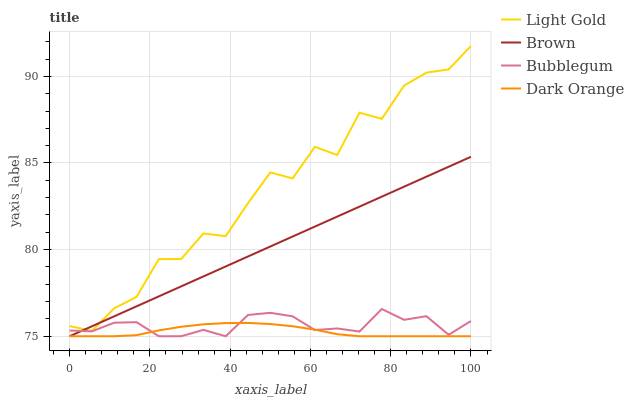Does Dark Orange have the minimum area under the curve?
Answer yes or no. Yes. Does Light Gold have the maximum area under the curve?
Answer yes or no. Yes. Does Bubblegum have the minimum area under the curve?
Answer yes or no. No. Does Bubblegum have the maximum area under the curve?
Answer yes or no. No. Is Brown the smoothest?
Answer yes or no. Yes. Is Light Gold the roughest?
Answer yes or no. Yes. Is Bubblegum the smoothest?
Answer yes or no. No. Is Bubblegum the roughest?
Answer yes or no. No. Does Light Gold have the lowest value?
Answer yes or no. No. Does Bubblegum have the highest value?
Answer yes or no. No. Is Bubblegum less than Light Gold?
Answer yes or no. Yes. Is Light Gold greater than Bubblegum?
Answer yes or no. Yes. Does Bubblegum intersect Light Gold?
Answer yes or no. No. 